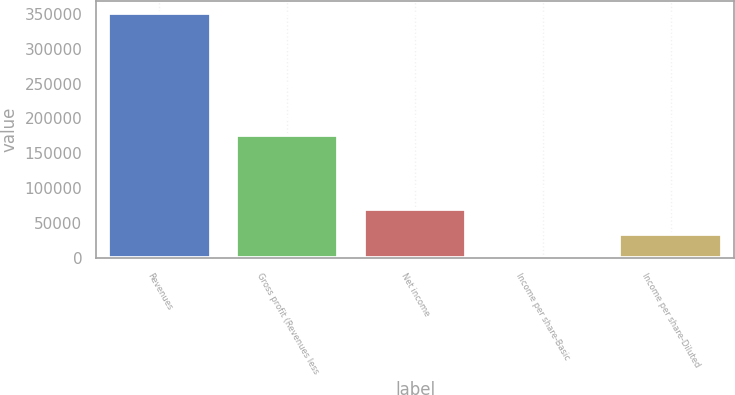<chart> <loc_0><loc_0><loc_500><loc_500><bar_chart><fcel>Revenues<fcel>Gross profit (Revenues less<fcel>Net income<fcel>Income per share-Basic<fcel>Income per share-Diluted<nl><fcel>350798<fcel>176437<fcel>70159.8<fcel>0.25<fcel>35080<nl></chart> 